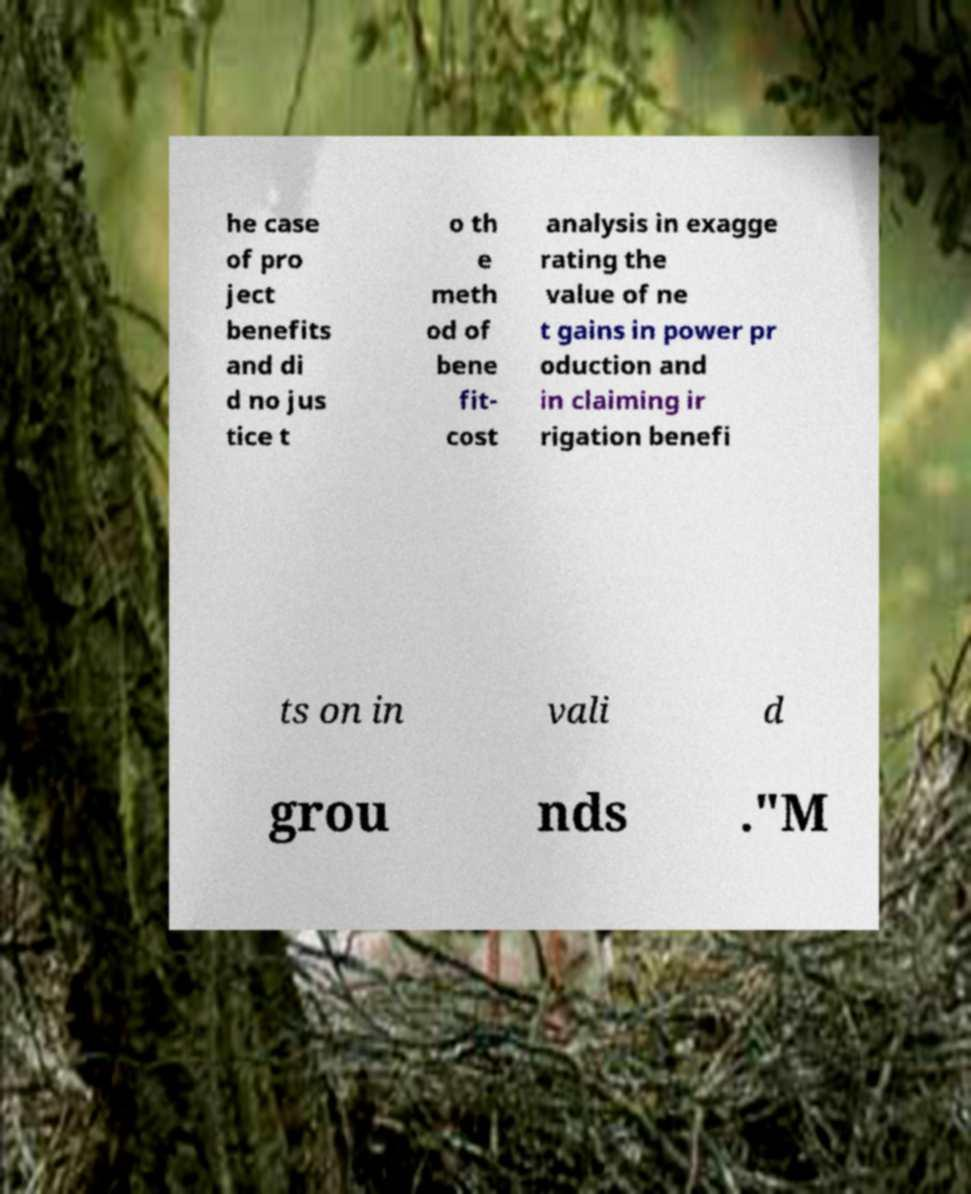Can you read and provide the text displayed in the image?This photo seems to have some interesting text. Can you extract and type it out for me? he case of pro ject benefits and di d no jus tice t o th e meth od of bene fit- cost analysis in exagge rating the value of ne t gains in power pr oduction and in claiming ir rigation benefi ts on in vali d grou nds ."M 